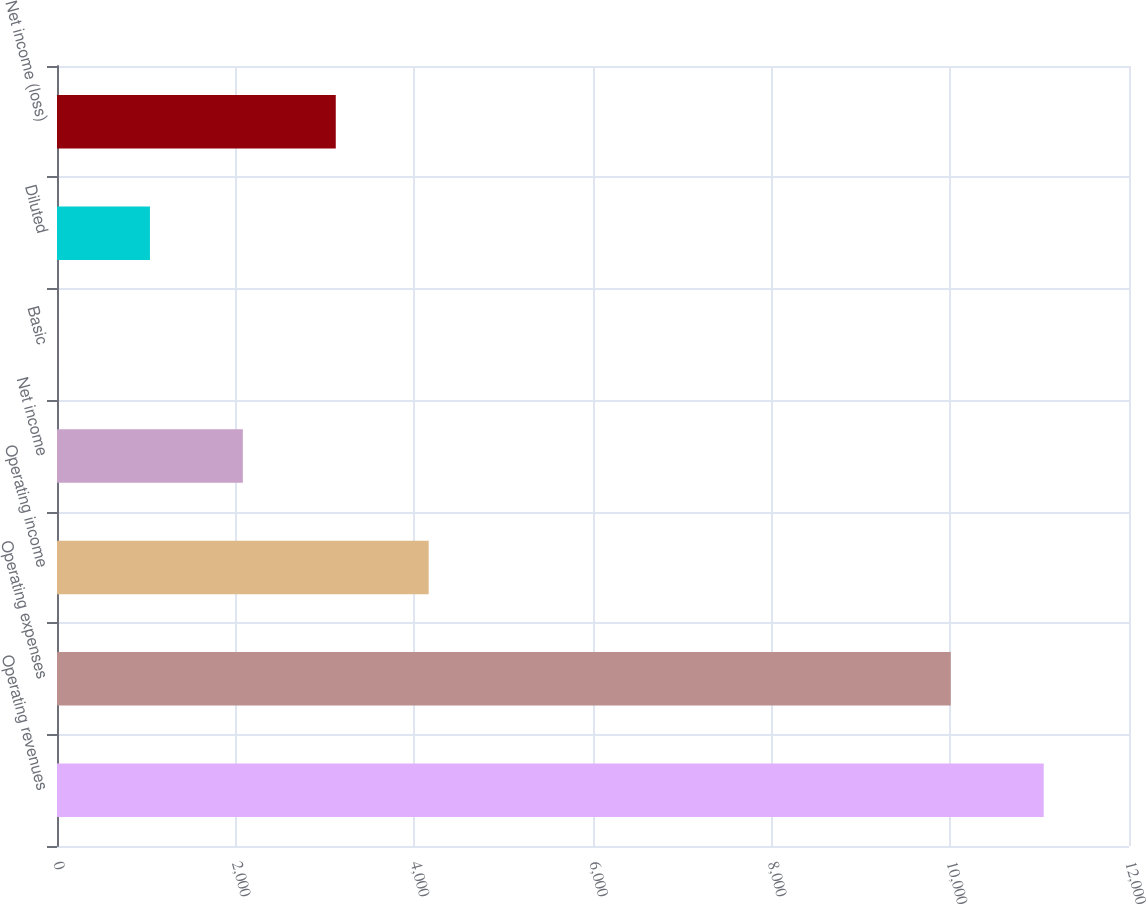Convert chart. <chart><loc_0><loc_0><loc_500><loc_500><bar_chart><fcel>Operating revenues<fcel>Operating expenses<fcel>Operating income<fcel>Net income<fcel>Basic<fcel>Diluted<fcel>Net income (loss)<nl><fcel>11045.1<fcel>10005<fcel>4160.62<fcel>2080.48<fcel>0.34<fcel>1040.41<fcel>3120.55<nl></chart> 